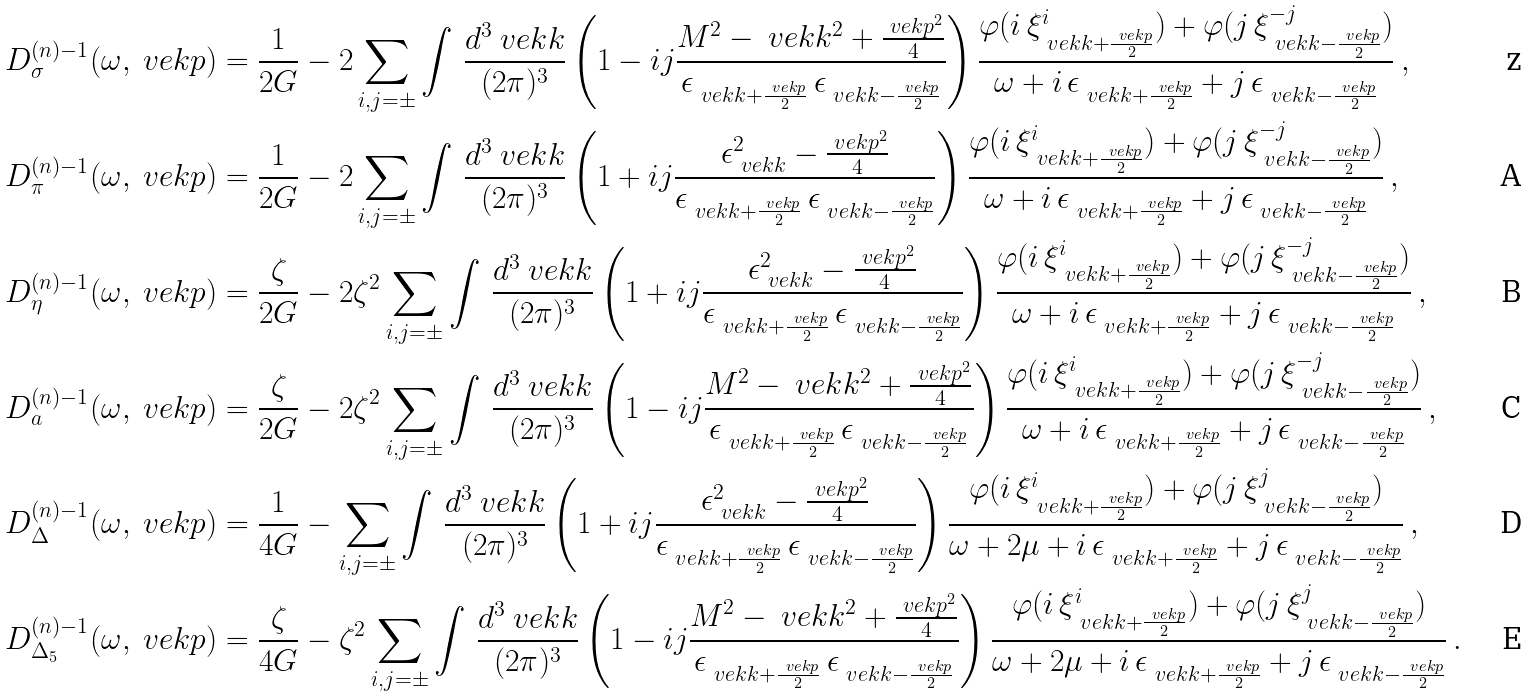<formula> <loc_0><loc_0><loc_500><loc_500>D ^ { ( n ) - 1 } _ { \sigma } ( \omega , \ v e k p ) & = \frac { 1 } { 2 G } - 2 \sum _ { i , j = \pm } \int \, \frac { d ^ { 3 } \ v e k k } { ( 2 \pi ) ^ { 3 } } \left ( 1 - i j \frac { M ^ { 2 } - \ v e k k ^ { 2 } + \frac { \ v e k p ^ { 2 } } { 4 } } { \epsilon _ { \ v e k k + \frac { \ v e k p } { 2 } } \, \epsilon _ { \ v e k k - \frac { \ v e k p } { 2 } } } \right ) \frac { \varphi ( i \, \xi ^ { i } _ { \ v e k k + \frac { \ v e k p } { 2 } } ) + \varphi ( j \, \xi ^ { - j } _ { \ v e k k - \frac { \ v e k p } { 2 } } ) } { \omega + i \, \epsilon _ { \ v e k k + \frac { \ v e k p } { 2 } } + j \, \epsilon _ { \ v e k k - \frac { \ v e k p } { 2 } } } \, , \\ D ^ { ( n ) - 1 } _ { \pi } ( \omega , \ v e k p ) & = \frac { 1 } { 2 G } - 2 \sum _ { i , j = \pm } \int \, \frac { d ^ { 3 } \ v e k k } { ( 2 \pi ) ^ { 3 } } \left ( 1 + i j \frac { \epsilon _ { \ v e k k } ^ { 2 } - \frac { \ v e k p ^ { 2 } } { 4 } } { \epsilon _ { \ v e k k + \frac { \ v e k p } { 2 } } \, \epsilon _ { \ v e k k - \frac { \ v e k p } { 2 } } } \right ) \frac { \varphi ( i \, \xi ^ { i } _ { \ v e k k + \frac { \ v e k p } { 2 } } ) + \varphi ( j \, \xi ^ { - j } _ { \ v e k k - \frac { \ v e k p } { 2 } } ) } { \omega + i \, \epsilon _ { \ v e k k + \frac { \ v e k p } { 2 } } + j \, \epsilon _ { \ v e k k - \frac { \ v e k p } { 2 } } } \, , \\ D ^ { ( n ) - 1 } _ { \eta } ( \omega , \ v e k p ) & = \frac { \zeta } { 2 G } - 2 \zeta ^ { 2 } \sum _ { i , j = \pm } \int \, \frac { d ^ { 3 } \ v e k k } { ( 2 \pi ) ^ { 3 } } \left ( 1 + i j \frac { \epsilon _ { \ v e k k } ^ { 2 } - \frac { \ v e k p ^ { 2 } } { 4 } } { \epsilon _ { \ v e k k + \frac { \ v e k p } { 2 } } \, \epsilon _ { \ v e k k - \frac { \ v e k p } { 2 } } } \right ) \frac { \varphi ( i \, \xi ^ { i } _ { \ v e k k + \frac { \ v e k p } { 2 } } ) + \varphi ( j \, \xi ^ { - j } _ { \ v e k k - \frac { \ v e k p } { 2 } } ) } { \omega + i \, \epsilon _ { \ v e k k + \frac { \ v e k p } { 2 } } + j \, \epsilon _ { \ v e k k - \frac { \ v e k p } { 2 } } } \, , \\ D ^ { ( n ) - 1 } _ { a } ( \omega , \ v e k p ) & = \frac { \zeta } { 2 G } - 2 \zeta ^ { 2 } \sum _ { i , j = \pm } \int \, \frac { d ^ { 3 } \ v e k k } { ( 2 \pi ) ^ { 3 } } \left ( 1 - i j \frac { M ^ { 2 } - \ v e k k ^ { 2 } + \frac { \ v e k p ^ { 2 } } { 4 } } { \epsilon _ { \ v e k k + \frac { \ v e k p } { 2 } } \, \epsilon _ { \ v e k k - \frac { \ v e k p } { 2 } } } \right ) \frac { \varphi ( i \, \xi ^ { i } _ { \ v e k k + \frac { \ v e k p } { 2 } } ) + \varphi ( j \, \xi ^ { - j } _ { \ v e k k - \frac { \ v e k p } { 2 } } ) } { \omega + i \, \epsilon _ { \ v e k k + \frac { \ v e k p } { 2 } } + j \, \epsilon _ { \ v e k k - \frac { \ v e k p } { 2 } } } \, , \\ D ^ { ( n ) - 1 } _ { \Delta } ( \omega , \ v e k p ) & = \frac { 1 } { 4 G } - \sum _ { i , j = \pm } \int \, \frac { d ^ { 3 } \ v e k k } { ( 2 \pi ) ^ { 3 } } \left ( 1 + i j \frac { \epsilon _ { \ v e k k } ^ { 2 } - \frac { \ v e k p ^ { 2 } } { 4 } } { \epsilon _ { \ v e k k + \frac { \ v e k p } { 2 } } \, \epsilon _ { \ v e k k - \frac { \ v e k p } { 2 } } } \right ) \frac { \varphi ( i \, \xi ^ { i } _ { \ v e k k + \frac { \ v e k p } { 2 } } ) + \varphi ( j \, \xi ^ { j } _ { \ v e k k - \frac { \ v e k p } { 2 } } ) } { \omega + 2 \mu + i \, \epsilon _ { \ v e k k + \frac { \ v e k p } { 2 } } + j \, \epsilon _ { \ v e k k - \frac { \ v e k p } { 2 } } } \, , \\ D ^ { ( n ) - 1 } _ { \Delta _ { 5 } } ( \omega , \ v e k p ) & = \frac { \zeta } { 4 G } - \zeta ^ { 2 } \sum _ { i , j = \pm } \int \, \frac { d ^ { 3 } \ v e k k } { ( 2 \pi ) ^ { 3 } } \left ( 1 - i j \frac { M ^ { 2 } - \ v e k k ^ { 2 } + \frac { \ v e k p ^ { 2 } } { 4 } } { \epsilon _ { \ v e k k + \frac { \ v e k p } { 2 } } \, \epsilon _ { \ v e k k - \frac { \ v e k p } { 2 } } } \right ) \frac { \varphi ( i \, \xi ^ { i } _ { \ v e k k + \frac { \ v e k p } { 2 } } ) + \varphi ( j \, \xi ^ { j } _ { \ v e k k - \frac { \ v e k p } { 2 } } ) } { \omega + 2 \mu + i \, \epsilon _ { \ v e k k + \frac { \ v e k p } { 2 } } + j \, \epsilon _ { \ v e k k - \frac { \ v e k p } { 2 } } } \, .</formula> 